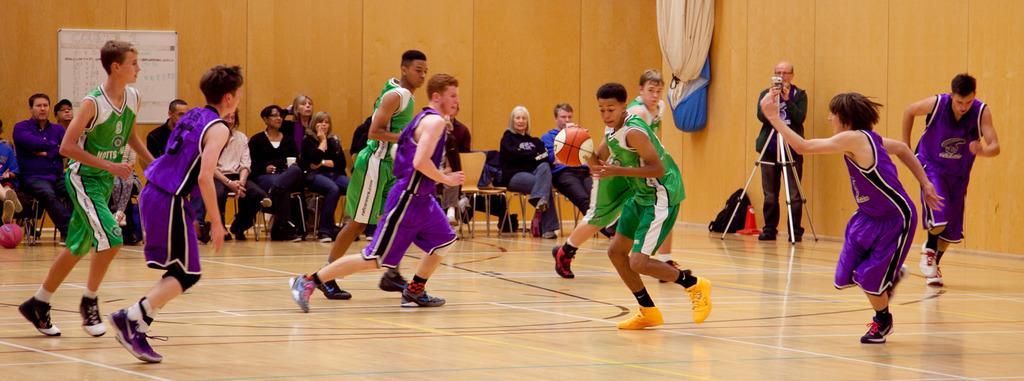Describe this image in one or two sentences. In this image I can see group of people playing game, they are wearing purple and green color dress. In front I can see a ball in brown and white color, background I can see a camera and group of people sitting on the chairs and I can see a white color board attached to the wall and the wall is in brown color. 